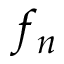<formula> <loc_0><loc_0><loc_500><loc_500>f _ { n }</formula> 